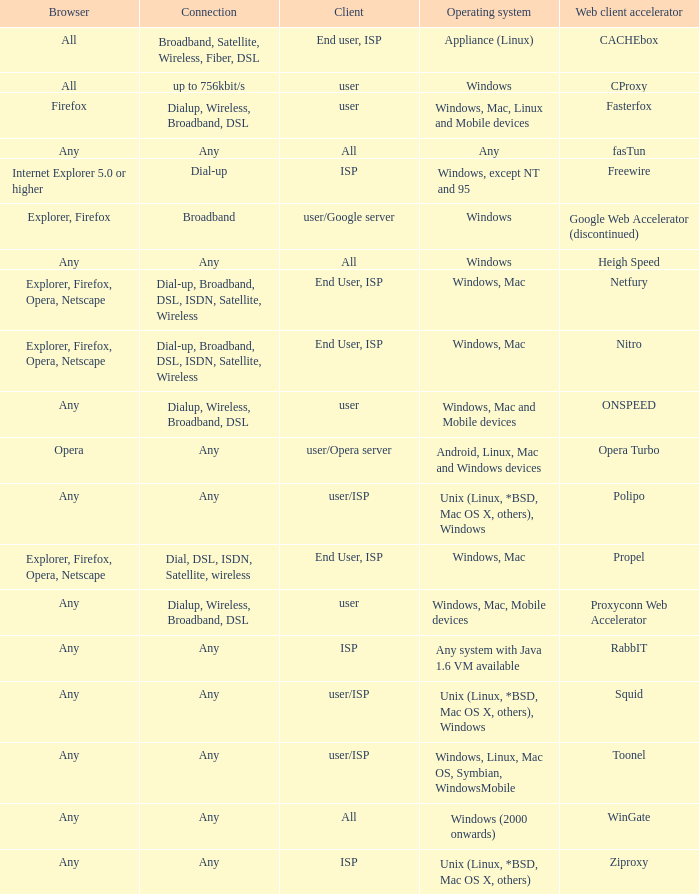What is the connection for the proxyconn web accelerator web client accelerator? Dialup, Wireless, Broadband, DSL. 